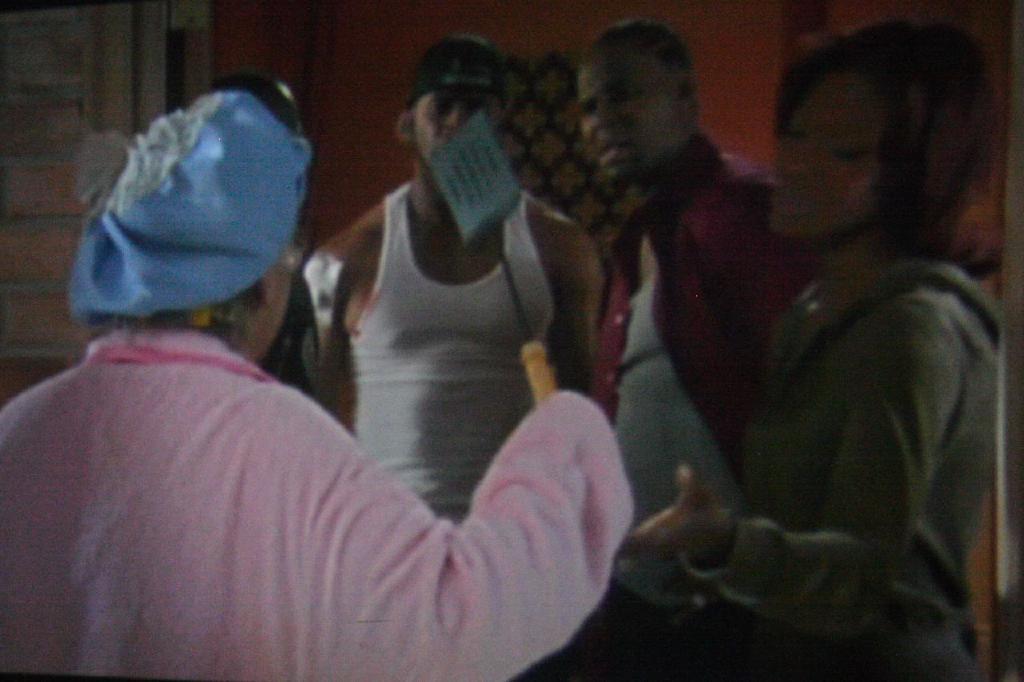How would you summarize this image in a sentence or two? Here in this picture we can see a group of people standing over there and the woman in the front is holding a spatula spoon in her hand. 